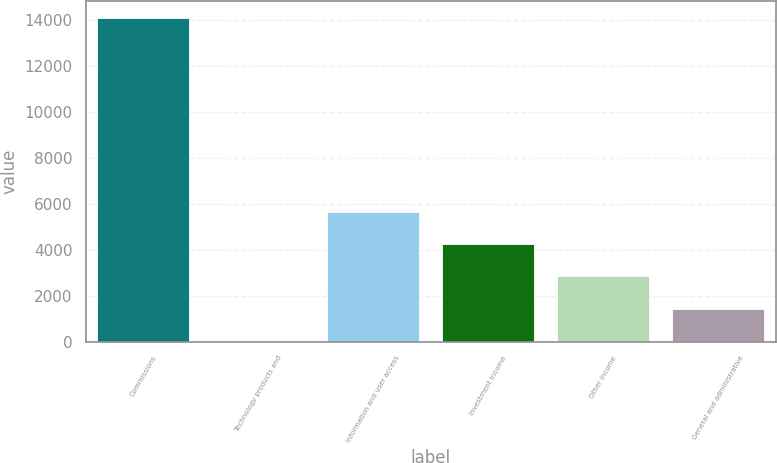Convert chart to OTSL. <chart><loc_0><loc_0><loc_500><loc_500><bar_chart><fcel>Commissions<fcel>Technology products and<fcel>Information and user access<fcel>Investment income<fcel>Other income<fcel>General and administrative<nl><fcel>14103<fcel>35<fcel>5662.2<fcel>4255.4<fcel>2848.6<fcel>1441.8<nl></chart> 